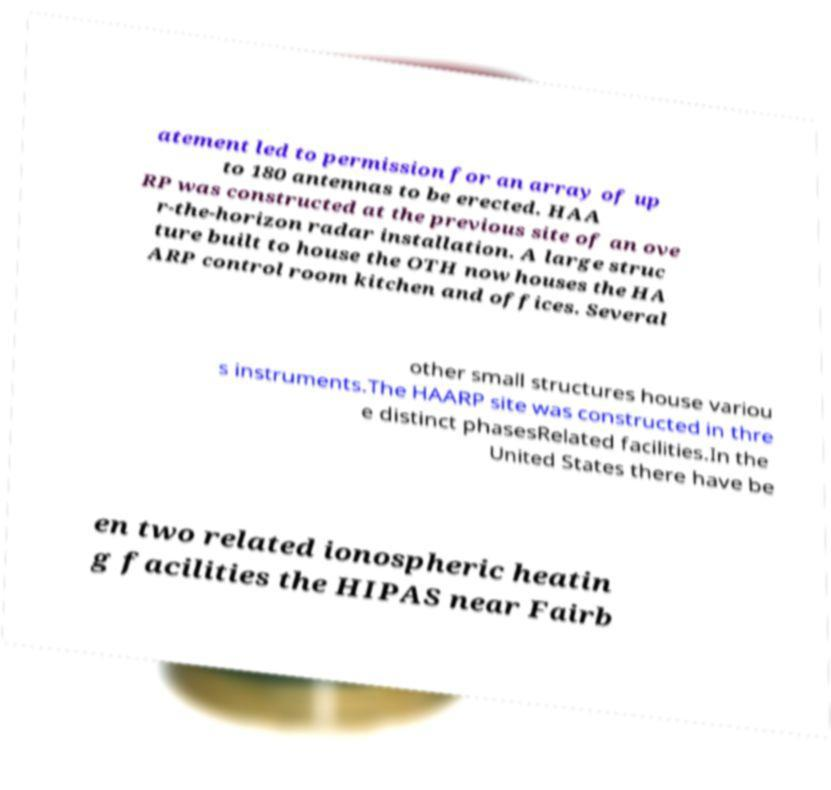Can you accurately transcribe the text from the provided image for me? atement led to permission for an array of up to 180 antennas to be erected. HAA RP was constructed at the previous site of an ove r-the-horizon radar installation. A large struc ture built to house the OTH now houses the HA ARP control room kitchen and offices. Several other small structures house variou s instruments.The HAARP site was constructed in thre e distinct phasesRelated facilities.In the United States there have be en two related ionospheric heatin g facilities the HIPAS near Fairb 